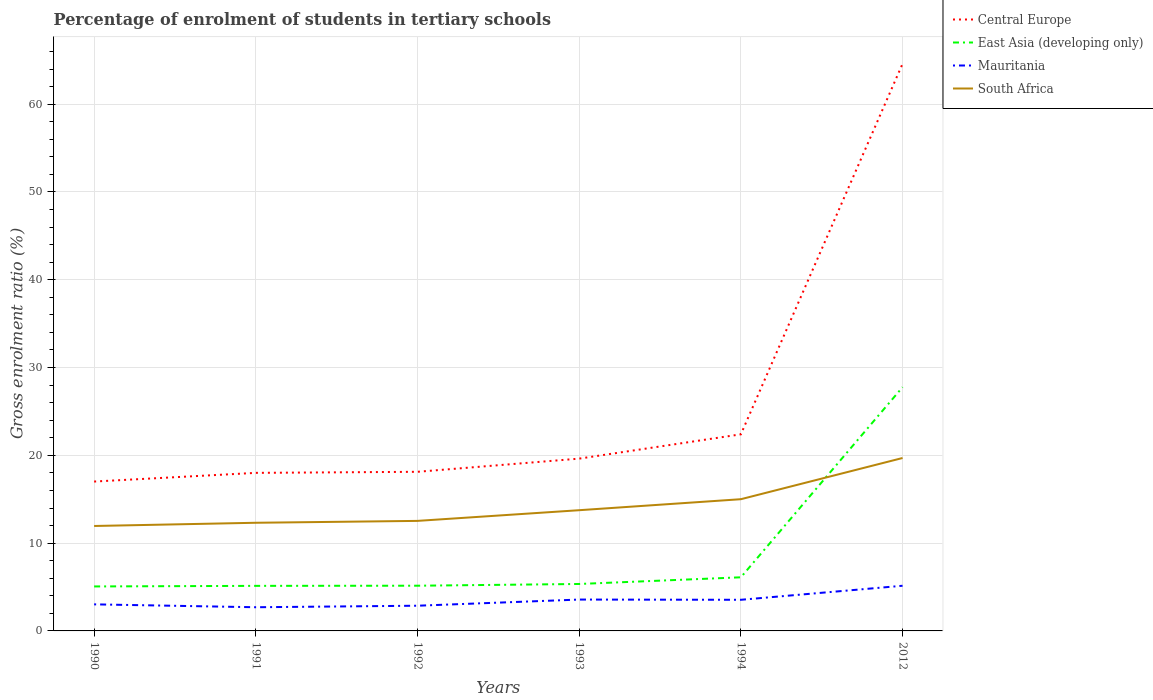How many different coloured lines are there?
Provide a short and direct response. 4. Is the number of lines equal to the number of legend labels?
Your response must be concise. Yes. Across all years, what is the maximum percentage of students enrolled in tertiary schools in East Asia (developing only)?
Your answer should be very brief. 5.07. What is the total percentage of students enrolled in tertiary schools in Mauritania in the graph?
Your answer should be very brief. -0.85. What is the difference between the highest and the second highest percentage of students enrolled in tertiary schools in Mauritania?
Keep it short and to the point. 2.45. What is the difference between the highest and the lowest percentage of students enrolled in tertiary schools in Mauritania?
Offer a very short reply. 3. How many lines are there?
Your answer should be very brief. 4. Does the graph contain grids?
Offer a very short reply. Yes. Where does the legend appear in the graph?
Offer a terse response. Top right. How are the legend labels stacked?
Offer a terse response. Vertical. What is the title of the graph?
Offer a terse response. Percentage of enrolment of students in tertiary schools. What is the label or title of the X-axis?
Keep it short and to the point. Years. What is the label or title of the Y-axis?
Provide a succinct answer. Gross enrolment ratio (%). What is the Gross enrolment ratio (%) in Central Europe in 1990?
Offer a very short reply. 17.02. What is the Gross enrolment ratio (%) in East Asia (developing only) in 1990?
Provide a short and direct response. 5.07. What is the Gross enrolment ratio (%) in Mauritania in 1990?
Your answer should be compact. 3.03. What is the Gross enrolment ratio (%) of South Africa in 1990?
Keep it short and to the point. 11.95. What is the Gross enrolment ratio (%) in Central Europe in 1991?
Provide a short and direct response. 18. What is the Gross enrolment ratio (%) in East Asia (developing only) in 1991?
Keep it short and to the point. 5.13. What is the Gross enrolment ratio (%) in Mauritania in 1991?
Your answer should be compact. 2.7. What is the Gross enrolment ratio (%) of South Africa in 1991?
Provide a succinct answer. 12.32. What is the Gross enrolment ratio (%) of Central Europe in 1992?
Provide a succinct answer. 18.13. What is the Gross enrolment ratio (%) in East Asia (developing only) in 1992?
Your response must be concise. 5.15. What is the Gross enrolment ratio (%) in Mauritania in 1992?
Give a very brief answer. 2.87. What is the Gross enrolment ratio (%) of South Africa in 1992?
Your answer should be compact. 12.53. What is the Gross enrolment ratio (%) of Central Europe in 1993?
Offer a terse response. 19.63. What is the Gross enrolment ratio (%) in East Asia (developing only) in 1993?
Your answer should be very brief. 5.35. What is the Gross enrolment ratio (%) in Mauritania in 1993?
Ensure brevity in your answer.  3.57. What is the Gross enrolment ratio (%) in South Africa in 1993?
Provide a succinct answer. 13.75. What is the Gross enrolment ratio (%) of Central Europe in 1994?
Your answer should be compact. 22.4. What is the Gross enrolment ratio (%) of East Asia (developing only) in 1994?
Your response must be concise. 6.11. What is the Gross enrolment ratio (%) in Mauritania in 1994?
Make the answer very short. 3.55. What is the Gross enrolment ratio (%) in South Africa in 1994?
Your answer should be very brief. 15. What is the Gross enrolment ratio (%) in Central Europe in 2012?
Ensure brevity in your answer.  64.61. What is the Gross enrolment ratio (%) of East Asia (developing only) in 2012?
Ensure brevity in your answer.  27.76. What is the Gross enrolment ratio (%) in Mauritania in 2012?
Your answer should be compact. 5.14. What is the Gross enrolment ratio (%) of South Africa in 2012?
Provide a succinct answer. 19.7. Across all years, what is the maximum Gross enrolment ratio (%) of Central Europe?
Offer a terse response. 64.61. Across all years, what is the maximum Gross enrolment ratio (%) in East Asia (developing only)?
Your answer should be very brief. 27.76. Across all years, what is the maximum Gross enrolment ratio (%) in Mauritania?
Make the answer very short. 5.14. Across all years, what is the maximum Gross enrolment ratio (%) of South Africa?
Your answer should be compact. 19.7. Across all years, what is the minimum Gross enrolment ratio (%) in Central Europe?
Offer a very short reply. 17.02. Across all years, what is the minimum Gross enrolment ratio (%) of East Asia (developing only)?
Your answer should be very brief. 5.07. Across all years, what is the minimum Gross enrolment ratio (%) in Mauritania?
Offer a very short reply. 2.7. Across all years, what is the minimum Gross enrolment ratio (%) of South Africa?
Your response must be concise. 11.95. What is the total Gross enrolment ratio (%) of Central Europe in the graph?
Provide a succinct answer. 159.77. What is the total Gross enrolment ratio (%) of East Asia (developing only) in the graph?
Provide a short and direct response. 54.57. What is the total Gross enrolment ratio (%) of Mauritania in the graph?
Offer a terse response. 20.86. What is the total Gross enrolment ratio (%) in South Africa in the graph?
Make the answer very short. 85.26. What is the difference between the Gross enrolment ratio (%) in Central Europe in 1990 and that in 1991?
Offer a very short reply. -0.99. What is the difference between the Gross enrolment ratio (%) in East Asia (developing only) in 1990 and that in 1991?
Give a very brief answer. -0.07. What is the difference between the Gross enrolment ratio (%) in Mauritania in 1990 and that in 1991?
Ensure brevity in your answer.  0.33. What is the difference between the Gross enrolment ratio (%) of South Africa in 1990 and that in 1991?
Ensure brevity in your answer.  -0.37. What is the difference between the Gross enrolment ratio (%) of Central Europe in 1990 and that in 1992?
Your response must be concise. -1.11. What is the difference between the Gross enrolment ratio (%) in East Asia (developing only) in 1990 and that in 1992?
Give a very brief answer. -0.08. What is the difference between the Gross enrolment ratio (%) in Mauritania in 1990 and that in 1992?
Ensure brevity in your answer.  0.16. What is the difference between the Gross enrolment ratio (%) of South Africa in 1990 and that in 1992?
Offer a very short reply. -0.58. What is the difference between the Gross enrolment ratio (%) in Central Europe in 1990 and that in 1993?
Provide a succinct answer. -2.61. What is the difference between the Gross enrolment ratio (%) of East Asia (developing only) in 1990 and that in 1993?
Give a very brief answer. -0.28. What is the difference between the Gross enrolment ratio (%) in Mauritania in 1990 and that in 1993?
Offer a terse response. -0.55. What is the difference between the Gross enrolment ratio (%) of South Africa in 1990 and that in 1993?
Your answer should be compact. -1.8. What is the difference between the Gross enrolment ratio (%) of Central Europe in 1990 and that in 1994?
Provide a succinct answer. -5.38. What is the difference between the Gross enrolment ratio (%) in East Asia (developing only) in 1990 and that in 1994?
Offer a very short reply. -1.04. What is the difference between the Gross enrolment ratio (%) in Mauritania in 1990 and that in 1994?
Offer a very short reply. -0.52. What is the difference between the Gross enrolment ratio (%) of South Africa in 1990 and that in 1994?
Your response must be concise. -3.05. What is the difference between the Gross enrolment ratio (%) of Central Europe in 1990 and that in 2012?
Your answer should be very brief. -47.59. What is the difference between the Gross enrolment ratio (%) of East Asia (developing only) in 1990 and that in 2012?
Your answer should be compact. -22.7. What is the difference between the Gross enrolment ratio (%) of Mauritania in 1990 and that in 2012?
Make the answer very short. -2.12. What is the difference between the Gross enrolment ratio (%) in South Africa in 1990 and that in 2012?
Your answer should be very brief. -7.74. What is the difference between the Gross enrolment ratio (%) in Central Europe in 1991 and that in 1992?
Ensure brevity in your answer.  -0.12. What is the difference between the Gross enrolment ratio (%) in East Asia (developing only) in 1991 and that in 1992?
Your answer should be compact. -0.02. What is the difference between the Gross enrolment ratio (%) in Mauritania in 1991 and that in 1992?
Offer a very short reply. -0.17. What is the difference between the Gross enrolment ratio (%) of South Africa in 1991 and that in 1992?
Ensure brevity in your answer.  -0.21. What is the difference between the Gross enrolment ratio (%) of Central Europe in 1991 and that in 1993?
Your answer should be very brief. -1.62. What is the difference between the Gross enrolment ratio (%) of East Asia (developing only) in 1991 and that in 1993?
Offer a terse response. -0.21. What is the difference between the Gross enrolment ratio (%) in Mauritania in 1991 and that in 1993?
Offer a terse response. -0.88. What is the difference between the Gross enrolment ratio (%) in South Africa in 1991 and that in 1993?
Make the answer very short. -1.43. What is the difference between the Gross enrolment ratio (%) of Central Europe in 1991 and that in 1994?
Make the answer very short. -4.39. What is the difference between the Gross enrolment ratio (%) of East Asia (developing only) in 1991 and that in 1994?
Provide a succinct answer. -0.98. What is the difference between the Gross enrolment ratio (%) in Mauritania in 1991 and that in 1994?
Offer a terse response. -0.85. What is the difference between the Gross enrolment ratio (%) in South Africa in 1991 and that in 1994?
Provide a succinct answer. -2.68. What is the difference between the Gross enrolment ratio (%) of Central Europe in 1991 and that in 2012?
Your answer should be compact. -46.6. What is the difference between the Gross enrolment ratio (%) in East Asia (developing only) in 1991 and that in 2012?
Your answer should be compact. -22.63. What is the difference between the Gross enrolment ratio (%) in Mauritania in 1991 and that in 2012?
Provide a succinct answer. -2.45. What is the difference between the Gross enrolment ratio (%) in South Africa in 1991 and that in 2012?
Keep it short and to the point. -7.38. What is the difference between the Gross enrolment ratio (%) in Central Europe in 1992 and that in 1993?
Provide a short and direct response. -1.5. What is the difference between the Gross enrolment ratio (%) in East Asia (developing only) in 1992 and that in 1993?
Ensure brevity in your answer.  -0.2. What is the difference between the Gross enrolment ratio (%) of Mauritania in 1992 and that in 1993?
Make the answer very short. -0.7. What is the difference between the Gross enrolment ratio (%) in South Africa in 1992 and that in 1993?
Give a very brief answer. -1.22. What is the difference between the Gross enrolment ratio (%) of Central Europe in 1992 and that in 1994?
Your response must be concise. -4.27. What is the difference between the Gross enrolment ratio (%) in East Asia (developing only) in 1992 and that in 1994?
Your answer should be very brief. -0.96. What is the difference between the Gross enrolment ratio (%) of Mauritania in 1992 and that in 1994?
Offer a very short reply. -0.68. What is the difference between the Gross enrolment ratio (%) in South Africa in 1992 and that in 1994?
Make the answer very short. -2.47. What is the difference between the Gross enrolment ratio (%) of Central Europe in 1992 and that in 2012?
Offer a very short reply. -46.48. What is the difference between the Gross enrolment ratio (%) of East Asia (developing only) in 1992 and that in 2012?
Keep it short and to the point. -22.61. What is the difference between the Gross enrolment ratio (%) of Mauritania in 1992 and that in 2012?
Provide a short and direct response. -2.27. What is the difference between the Gross enrolment ratio (%) of South Africa in 1992 and that in 2012?
Offer a very short reply. -7.16. What is the difference between the Gross enrolment ratio (%) in Central Europe in 1993 and that in 1994?
Provide a short and direct response. -2.77. What is the difference between the Gross enrolment ratio (%) in East Asia (developing only) in 1993 and that in 1994?
Ensure brevity in your answer.  -0.76. What is the difference between the Gross enrolment ratio (%) in Mauritania in 1993 and that in 1994?
Provide a short and direct response. 0.03. What is the difference between the Gross enrolment ratio (%) in South Africa in 1993 and that in 1994?
Make the answer very short. -1.25. What is the difference between the Gross enrolment ratio (%) of Central Europe in 1993 and that in 2012?
Your answer should be very brief. -44.98. What is the difference between the Gross enrolment ratio (%) in East Asia (developing only) in 1993 and that in 2012?
Offer a terse response. -22.42. What is the difference between the Gross enrolment ratio (%) in Mauritania in 1993 and that in 2012?
Your answer should be compact. -1.57. What is the difference between the Gross enrolment ratio (%) in South Africa in 1993 and that in 2012?
Offer a very short reply. -5.95. What is the difference between the Gross enrolment ratio (%) in Central Europe in 1994 and that in 2012?
Provide a short and direct response. -42.21. What is the difference between the Gross enrolment ratio (%) of East Asia (developing only) in 1994 and that in 2012?
Provide a succinct answer. -21.66. What is the difference between the Gross enrolment ratio (%) in Mauritania in 1994 and that in 2012?
Your response must be concise. -1.6. What is the difference between the Gross enrolment ratio (%) in South Africa in 1994 and that in 2012?
Make the answer very short. -4.69. What is the difference between the Gross enrolment ratio (%) in Central Europe in 1990 and the Gross enrolment ratio (%) in East Asia (developing only) in 1991?
Your answer should be compact. 11.88. What is the difference between the Gross enrolment ratio (%) in Central Europe in 1990 and the Gross enrolment ratio (%) in Mauritania in 1991?
Provide a succinct answer. 14.32. What is the difference between the Gross enrolment ratio (%) in Central Europe in 1990 and the Gross enrolment ratio (%) in South Africa in 1991?
Make the answer very short. 4.7. What is the difference between the Gross enrolment ratio (%) of East Asia (developing only) in 1990 and the Gross enrolment ratio (%) of Mauritania in 1991?
Keep it short and to the point. 2.37. What is the difference between the Gross enrolment ratio (%) in East Asia (developing only) in 1990 and the Gross enrolment ratio (%) in South Africa in 1991?
Offer a terse response. -7.25. What is the difference between the Gross enrolment ratio (%) of Mauritania in 1990 and the Gross enrolment ratio (%) of South Africa in 1991?
Ensure brevity in your answer.  -9.29. What is the difference between the Gross enrolment ratio (%) in Central Europe in 1990 and the Gross enrolment ratio (%) in East Asia (developing only) in 1992?
Give a very brief answer. 11.87. What is the difference between the Gross enrolment ratio (%) in Central Europe in 1990 and the Gross enrolment ratio (%) in Mauritania in 1992?
Offer a terse response. 14.14. What is the difference between the Gross enrolment ratio (%) in Central Europe in 1990 and the Gross enrolment ratio (%) in South Africa in 1992?
Make the answer very short. 4.48. What is the difference between the Gross enrolment ratio (%) of East Asia (developing only) in 1990 and the Gross enrolment ratio (%) of Mauritania in 1992?
Make the answer very short. 2.2. What is the difference between the Gross enrolment ratio (%) of East Asia (developing only) in 1990 and the Gross enrolment ratio (%) of South Africa in 1992?
Your answer should be compact. -7.47. What is the difference between the Gross enrolment ratio (%) of Mauritania in 1990 and the Gross enrolment ratio (%) of South Africa in 1992?
Make the answer very short. -9.51. What is the difference between the Gross enrolment ratio (%) of Central Europe in 1990 and the Gross enrolment ratio (%) of East Asia (developing only) in 1993?
Offer a very short reply. 11.67. What is the difference between the Gross enrolment ratio (%) of Central Europe in 1990 and the Gross enrolment ratio (%) of Mauritania in 1993?
Offer a very short reply. 13.44. What is the difference between the Gross enrolment ratio (%) of Central Europe in 1990 and the Gross enrolment ratio (%) of South Africa in 1993?
Provide a short and direct response. 3.26. What is the difference between the Gross enrolment ratio (%) in East Asia (developing only) in 1990 and the Gross enrolment ratio (%) in Mauritania in 1993?
Offer a very short reply. 1.49. What is the difference between the Gross enrolment ratio (%) in East Asia (developing only) in 1990 and the Gross enrolment ratio (%) in South Africa in 1993?
Keep it short and to the point. -8.68. What is the difference between the Gross enrolment ratio (%) of Mauritania in 1990 and the Gross enrolment ratio (%) of South Africa in 1993?
Keep it short and to the point. -10.72. What is the difference between the Gross enrolment ratio (%) in Central Europe in 1990 and the Gross enrolment ratio (%) in East Asia (developing only) in 1994?
Offer a terse response. 10.91. What is the difference between the Gross enrolment ratio (%) of Central Europe in 1990 and the Gross enrolment ratio (%) of Mauritania in 1994?
Your response must be concise. 13.47. What is the difference between the Gross enrolment ratio (%) in Central Europe in 1990 and the Gross enrolment ratio (%) in South Africa in 1994?
Give a very brief answer. 2.01. What is the difference between the Gross enrolment ratio (%) of East Asia (developing only) in 1990 and the Gross enrolment ratio (%) of Mauritania in 1994?
Provide a short and direct response. 1.52. What is the difference between the Gross enrolment ratio (%) in East Asia (developing only) in 1990 and the Gross enrolment ratio (%) in South Africa in 1994?
Your answer should be compact. -9.94. What is the difference between the Gross enrolment ratio (%) of Mauritania in 1990 and the Gross enrolment ratio (%) of South Africa in 1994?
Give a very brief answer. -11.98. What is the difference between the Gross enrolment ratio (%) in Central Europe in 1990 and the Gross enrolment ratio (%) in East Asia (developing only) in 2012?
Provide a succinct answer. -10.75. What is the difference between the Gross enrolment ratio (%) in Central Europe in 1990 and the Gross enrolment ratio (%) in Mauritania in 2012?
Provide a short and direct response. 11.87. What is the difference between the Gross enrolment ratio (%) in Central Europe in 1990 and the Gross enrolment ratio (%) in South Africa in 2012?
Your answer should be very brief. -2.68. What is the difference between the Gross enrolment ratio (%) in East Asia (developing only) in 1990 and the Gross enrolment ratio (%) in Mauritania in 2012?
Offer a terse response. -0.08. What is the difference between the Gross enrolment ratio (%) of East Asia (developing only) in 1990 and the Gross enrolment ratio (%) of South Africa in 2012?
Give a very brief answer. -14.63. What is the difference between the Gross enrolment ratio (%) in Mauritania in 1990 and the Gross enrolment ratio (%) in South Africa in 2012?
Give a very brief answer. -16.67. What is the difference between the Gross enrolment ratio (%) of Central Europe in 1991 and the Gross enrolment ratio (%) of East Asia (developing only) in 1992?
Offer a terse response. 12.85. What is the difference between the Gross enrolment ratio (%) in Central Europe in 1991 and the Gross enrolment ratio (%) in Mauritania in 1992?
Provide a succinct answer. 15.13. What is the difference between the Gross enrolment ratio (%) of Central Europe in 1991 and the Gross enrolment ratio (%) of South Africa in 1992?
Make the answer very short. 5.47. What is the difference between the Gross enrolment ratio (%) in East Asia (developing only) in 1991 and the Gross enrolment ratio (%) in Mauritania in 1992?
Give a very brief answer. 2.26. What is the difference between the Gross enrolment ratio (%) of East Asia (developing only) in 1991 and the Gross enrolment ratio (%) of South Africa in 1992?
Give a very brief answer. -7.4. What is the difference between the Gross enrolment ratio (%) in Mauritania in 1991 and the Gross enrolment ratio (%) in South Africa in 1992?
Your answer should be very brief. -9.84. What is the difference between the Gross enrolment ratio (%) in Central Europe in 1991 and the Gross enrolment ratio (%) in East Asia (developing only) in 1993?
Provide a short and direct response. 12.66. What is the difference between the Gross enrolment ratio (%) of Central Europe in 1991 and the Gross enrolment ratio (%) of Mauritania in 1993?
Your answer should be very brief. 14.43. What is the difference between the Gross enrolment ratio (%) in Central Europe in 1991 and the Gross enrolment ratio (%) in South Africa in 1993?
Ensure brevity in your answer.  4.25. What is the difference between the Gross enrolment ratio (%) in East Asia (developing only) in 1991 and the Gross enrolment ratio (%) in Mauritania in 1993?
Make the answer very short. 1.56. What is the difference between the Gross enrolment ratio (%) in East Asia (developing only) in 1991 and the Gross enrolment ratio (%) in South Africa in 1993?
Ensure brevity in your answer.  -8.62. What is the difference between the Gross enrolment ratio (%) of Mauritania in 1991 and the Gross enrolment ratio (%) of South Africa in 1993?
Your response must be concise. -11.05. What is the difference between the Gross enrolment ratio (%) of Central Europe in 1991 and the Gross enrolment ratio (%) of East Asia (developing only) in 1994?
Keep it short and to the point. 11.9. What is the difference between the Gross enrolment ratio (%) of Central Europe in 1991 and the Gross enrolment ratio (%) of Mauritania in 1994?
Keep it short and to the point. 14.46. What is the difference between the Gross enrolment ratio (%) of East Asia (developing only) in 1991 and the Gross enrolment ratio (%) of Mauritania in 1994?
Offer a very short reply. 1.59. What is the difference between the Gross enrolment ratio (%) of East Asia (developing only) in 1991 and the Gross enrolment ratio (%) of South Africa in 1994?
Provide a short and direct response. -9.87. What is the difference between the Gross enrolment ratio (%) of Mauritania in 1991 and the Gross enrolment ratio (%) of South Africa in 1994?
Your answer should be very brief. -12.31. What is the difference between the Gross enrolment ratio (%) of Central Europe in 1991 and the Gross enrolment ratio (%) of East Asia (developing only) in 2012?
Offer a very short reply. -9.76. What is the difference between the Gross enrolment ratio (%) of Central Europe in 1991 and the Gross enrolment ratio (%) of Mauritania in 2012?
Your answer should be compact. 12.86. What is the difference between the Gross enrolment ratio (%) in Central Europe in 1991 and the Gross enrolment ratio (%) in South Africa in 2012?
Give a very brief answer. -1.69. What is the difference between the Gross enrolment ratio (%) in East Asia (developing only) in 1991 and the Gross enrolment ratio (%) in Mauritania in 2012?
Your answer should be compact. -0.01. What is the difference between the Gross enrolment ratio (%) of East Asia (developing only) in 1991 and the Gross enrolment ratio (%) of South Africa in 2012?
Offer a terse response. -14.56. What is the difference between the Gross enrolment ratio (%) in Mauritania in 1991 and the Gross enrolment ratio (%) in South Africa in 2012?
Make the answer very short. -17. What is the difference between the Gross enrolment ratio (%) in Central Europe in 1992 and the Gross enrolment ratio (%) in East Asia (developing only) in 1993?
Give a very brief answer. 12.78. What is the difference between the Gross enrolment ratio (%) in Central Europe in 1992 and the Gross enrolment ratio (%) in Mauritania in 1993?
Keep it short and to the point. 14.55. What is the difference between the Gross enrolment ratio (%) of Central Europe in 1992 and the Gross enrolment ratio (%) of South Africa in 1993?
Your answer should be compact. 4.37. What is the difference between the Gross enrolment ratio (%) in East Asia (developing only) in 1992 and the Gross enrolment ratio (%) in Mauritania in 1993?
Ensure brevity in your answer.  1.58. What is the difference between the Gross enrolment ratio (%) in East Asia (developing only) in 1992 and the Gross enrolment ratio (%) in South Africa in 1993?
Offer a very short reply. -8.6. What is the difference between the Gross enrolment ratio (%) of Mauritania in 1992 and the Gross enrolment ratio (%) of South Africa in 1993?
Offer a terse response. -10.88. What is the difference between the Gross enrolment ratio (%) in Central Europe in 1992 and the Gross enrolment ratio (%) in East Asia (developing only) in 1994?
Your answer should be very brief. 12.02. What is the difference between the Gross enrolment ratio (%) of Central Europe in 1992 and the Gross enrolment ratio (%) of Mauritania in 1994?
Provide a short and direct response. 14.58. What is the difference between the Gross enrolment ratio (%) of Central Europe in 1992 and the Gross enrolment ratio (%) of South Africa in 1994?
Provide a succinct answer. 3.12. What is the difference between the Gross enrolment ratio (%) of East Asia (developing only) in 1992 and the Gross enrolment ratio (%) of Mauritania in 1994?
Provide a short and direct response. 1.6. What is the difference between the Gross enrolment ratio (%) of East Asia (developing only) in 1992 and the Gross enrolment ratio (%) of South Africa in 1994?
Provide a short and direct response. -9.85. What is the difference between the Gross enrolment ratio (%) in Mauritania in 1992 and the Gross enrolment ratio (%) in South Africa in 1994?
Offer a terse response. -12.13. What is the difference between the Gross enrolment ratio (%) in Central Europe in 1992 and the Gross enrolment ratio (%) in East Asia (developing only) in 2012?
Your answer should be very brief. -9.64. What is the difference between the Gross enrolment ratio (%) of Central Europe in 1992 and the Gross enrolment ratio (%) of Mauritania in 2012?
Ensure brevity in your answer.  12.98. What is the difference between the Gross enrolment ratio (%) in Central Europe in 1992 and the Gross enrolment ratio (%) in South Africa in 2012?
Your answer should be very brief. -1.57. What is the difference between the Gross enrolment ratio (%) in East Asia (developing only) in 1992 and the Gross enrolment ratio (%) in Mauritania in 2012?
Keep it short and to the point. 0.01. What is the difference between the Gross enrolment ratio (%) in East Asia (developing only) in 1992 and the Gross enrolment ratio (%) in South Africa in 2012?
Provide a succinct answer. -14.55. What is the difference between the Gross enrolment ratio (%) in Mauritania in 1992 and the Gross enrolment ratio (%) in South Africa in 2012?
Your answer should be compact. -16.83. What is the difference between the Gross enrolment ratio (%) in Central Europe in 1993 and the Gross enrolment ratio (%) in East Asia (developing only) in 1994?
Your answer should be very brief. 13.52. What is the difference between the Gross enrolment ratio (%) of Central Europe in 1993 and the Gross enrolment ratio (%) of Mauritania in 1994?
Your answer should be very brief. 16.08. What is the difference between the Gross enrolment ratio (%) of Central Europe in 1993 and the Gross enrolment ratio (%) of South Africa in 1994?
Keep it short and to the point. 4.62. What is the difference between the Gross enrolment ratio (%) of East Asia (developing only) in 1993 and the Gross enrolment ratio (%) of Mauritania in 1994?
Make the answer very short. 1.8. What is the difference between the Gross enrolment ratio (%) of East Asia (developing only) in 1993 and the Gross enrolment ratio (%) of South Africa in 1994?
Offer a very short reply. -9.66. What is the difference between the Gross enrolment ratio (%) of Mauritania in 1993 and the Gross enrolment ratio (%) of South Africa in 1994?
Keep it short and to the point. -11.43. What is the difference between the Gross enrolment ratio (%) of Central Europe in 1993 and the Gross enrolment ratio (%) of East Asia (developing only) in 2012?
Ensure brevity in your answer.  -8.14. What is the difference between the Gross enrolment ratio (%) of Central Europe in 1993 and the Gross enrolment ratio (%) of Mauritania in 2012?
Your answer should be very brief. 14.48. What is the difference between the Gross enrolment ratio (%) in Central Europe in 1993 and the Gross enrolment ratio (%) in South Africa in 2012?
Your answer should be very brief. -0.07. What is the difference between the Gross enrolment ratio (%) in East Asia (developing only) in 1993 and the Gross enrolment ratio (%) in Mauritania in 2012?
Offer a very short reply. 0.2. What is the difference between the Gross enrolment ratio (%) in East Asia (developing only) in 1993 and the Gross enrolment ratio (%) in South Africa in 2012?
Provide a succinct answer. -14.35. What is the difference between the Gross enrolment ratio (%) of Mauritania in 1993 and the Gross enrolment ratio (%) of South Africa in 2012?
Give a very brief answer. -16.12. What is the difference between the Gross enrolment ratio (%) of Central Europe in 1994 and the Gross enrolment ratio (%) of East Asia (developing only) in 2012?
Provide a short and direct response. -5.37. What is the difference between the Gross enrolment ratio (%) of Central Europe in 1994 and the Gross enrolment ratio (%) of Mauritania in 2012?
Offer a terse response. 17.25. What is the difference between the Gross enrolment ratio (%) in Central Europe in 1994 and the Gross enrolment ratio (%) in South Africa in 2012?
Make the answer very short. 2.7. What is the difference between the Gross enrolment ratio (%) of East Asia (developing only) in 1994 and the Gross enrolment ratio (%) of Mauritania in 2012?
Your response must be concise. 0.96. What is the difference between the Gross enrolment ratio (%) in East Asia (developing only) in 1994 and the Gross enrolment ratio (%) in South Africa in 2012?
Your answer should be very brief. -13.59. What is the difference between the Gross enrolment ratio (%) of Mauritania in 1994 and the Gross enrolment ratio (%) of South Africa in 2012?
Make the answer very short. -16.15. What is the average Gross enrolment ratio (%) in Central Europe per year?
Give a very brief answer. 26.63. What is the average Gross enrolment ratio (%) of East Asia (developing only) per year?
Ensure brevity in your answer.  9.09. What is the average Gross enrolment ratio (%) of Mauritania per year?
Offer a terse response. 3.48. What is the average Gross enrolment ratio (%) of South Africa per year?
Your answer should be compact. 14.21. In the year 1990, what is the difference between the Gross enrolment ratio (%) of Central Europe and Gross enrolment ratio (%) of East Asia (developing only)?
Your response must be concise. 11.95. In the year 1990, what is the difference between the Gross enrolment ratio (%) of Central Europe and Gross enrolment ratio (%) of Mauritania?
Offer a terse response. 13.99. In the year 1990, what is the difference between the Gross enrolment ratio (%) in Central Europe and Gross enrolment ratio (%) in South Africa?
Give a very brief answer. 5.06. In the year 1990, what is the difference between the Gross enrolment ratio (%) of East Asia (developing only) and Gross enrolment ratio (%) of Mauritania?
Offer a terse response. 2.04. In the year 1990, what is the difference between the Gross enrolment ratio (%) in East Asia (developing only) and Gross enrolment ratio (%) in South Africa?
Your answer should be very brief. -6.89. In the year 1990, what is the difference between the Gross enrolment ratio (%) of Mauritania and Gross enrolment ratio (%) of South Africa?
Give a very brief answer. -8.93. In the year 1991, what is the difference between the Gross enrolment ratio (%) of Central Europe and Gross enrolment ratio (%) of East Asia (developing only)?
Provide a succinct answer. 12.87. In the year 1991, what is the difference between the Gross enrolment ratio (%) in Central Europe and Gross enrolment ratio (%) in Mauritania?
Make the answer very short. 15.31. In the year 1991, what is the difference between the Gross enrolment ratio (%) of Central Europe and Gross enrolment ratio (%) of South Africa?
Your response must be concise. 5.68. In the year 1991, what is the difference between the Gross enrolment ratio (%) in East Asia (developing only) and Gross enrolment ratio (%) in Mauritania?
Ensure brevity in your answer.  2.44. In the year 1991, what is the difference between the Gross enrolment ratio (%) of East Asia (developing only) and Gross enrolment ratio (%) of South Africa?
Offer a very short reply. -7.19. In the year 1991, what is the difference between the Gross enrolment ratio (%) of Mauritania and Gross enrolment ratio (%) of South Africa?
Provide a succinct answer. -9.62. In the year 1992, what is the difference between the Gross enrolment ratio (%) of Central Europe and Gross enrolment ratio (%) of East Asia (developing only)?
Keep it short and to the point. 12.98. In the year 1992, what is the difference between the Gross enrolment ratio (%) in Central Europe and Gross enrolment ratio (%) in Mauritania?
Provide a short and direct response. 15.25. In the year 1992, what is the difference between the Gross enrolment ratio (%) in Central Europe and Gross enrolment ratio (%) in South Africa?
Keep it short and to the point. 5.59. In the year 1992, what is the difference between the Gross enrolment ratio (%) in East Asia (developing only) and Gross enrolment ratio (%) in Mauritania?
Offer a terse response. 2.28. In the year 1992, what is the difference between the Gross enrolment ratio (%) in East Asia (developing only) and Gross enrolment ratio (%) in South Africa?
Provide a short and direct response. -7.38. In the year 1992, what is the difference between the Gross enrolment ratio (%) in Mauritania and Gross enrolment ratio (%) in South Africa?
Keep it short and to the point. -9.66. In the year 1993, what is the difference between the Gross enrolment ratio (%) of Central Europe and Gross enrolment ratio (%) of East Asia (developing only)?
Provide a succinct answer. 14.28. In the year 1993, what is the difference between the Gross enrolment ratio (%) of Central Europe and Gross enrolment ratio (%) of Mauritania?
Offer a very short reply. 16.05. In the year 1993, what is the difference between the Gross enrolment ratio (%) in Central Europe and Gross enrolment ratio (%) in South Africa?
Offer a very short reply. 5.87. In the year 1993, what is the difference between the Gross enrolment ratio (%) of East Asia (developing only) and Gross enrolment ratio (%) of Mauritania?
Your answer should be very brief. 1.77. In the year 1993, what is the difference between the Gross enrolment ratio (%) in East Asia (developing only) and Gross enrolment ratio (%) in South Africa?
Give a very brief answer. -8.4. In the year 1993, what is the difference between the Gross enrolment ratio (%) in Mauritania and Gross enrolment ratio (%) in South Africa?
Provide a short and direct response. -10.18. In the year 1994, what is the difference between the Gross enrolment ratio (%) of Central Europe and Gross enrolment ratio (%) of East Asia (developing only)?
Make the answer very short. 16.29. In the year 1994, what is the difference between the Gross enrolment ratio (%) in Central Europe and Gross enrolment ratio (%) in Mauritania?
Offer a terse response. 18.85. In the year 1994, what is the difference between the Gross enrolment ratio (%) in Central Europe and Gross enrolment ratio (%) in South Africa?
Your answer should be very brief. 7.39. In the year 1994, what is the difference between the Gross enrolment ratio (%) in East Asia (developing only) and Gross enrolment ratio (%) in Mauritania?
Make the answer very short. 2.56. In the year 1994, what is the difference between the Gross enrolment ratio (%) of East Asia (developing only) and Gross enrolment ratio (%) of South Africa?
Your response must be concise. -8.9. In the year 1994, what is the difference between the Gross enrolment ratio (%) in Mauritania and Gross enrolment ratio (%) in South Africa?
Make the answer very short. -11.46. In the year 2012, what is the difference between the Gross enrolment ratio (%) in Central Europe and Gross enrolment ratio (%) in East Asia (developing only)?
Offer a very short reply. 36.84. In the year 2012, what is the difference between the Gross enrolment ratio (%) in Central Europe and Gross enrolment ratio (%) in Mauritania?
Provide a short and direct response. 59.46. In the year 2012, what is the difference between the Gross enrolment ratio (%) of Central Europe and Gross enrolment ratio (%) of South Africa?
Provide a succinct answer. 44.91. In the year 2012, what is the difference between the Gross enrolment ratio (%) in East Asia (developing only) and Gross enrolment ratio (%) in Mauritania?
Your answer should be very brief. 22.62. In the year 2012, what is the difference between the Gross enrolment ratio (%) of East Asia (developing only) and Gross enrolment ratio (%) of South Africa?
Give a very brief answer. 8.07. In the year 2012, what is the difference between the Gross enrolment ratio (%) in Mauritania and Gross enrolment ratio (%) in South Africa?
Your response must be concise. -14.55. What is the ratio of the Gross enrolment ratio (%) in Central Europe in 1990 to that in 1991?
Provide a succinct answer. 0.95. What is the ratio of the Gross enrolment ratio (%) of East Asia (developing only) in 1990 to that in 1991?
Provide a succinct answer. 0.99. What is the ratio of the Gross enrolment ratio (%) of Mauritania in 1990 to that in 1991?
Offer a very short reply. 1.12. What is the ratio of the Gross enrolment ratio (%) of South Africa in 1990 to that in 1991?
Ensure brevity in your answer.  0.97. What is the ratio of the Gross enrolment ratio (%) of Central Europe in 1990 to that in 1992?
Offer a terse response. 0.94. What is the ratio of the Gross enrolment ratio (%) of East Asia (developing only) in 1990 to that in 1992?
Your response must be concise. 0.98. What is the ratio of the Gross enrolment ratio (%) of Mauritania in 1990 to that in 1992?
Offer a very short reply. 1.05. What is the ratio of the Gross enrolment ratio (%) of South Africa in 1990 to that in 1992?
Offer a very short reply. 0.95. What is the ratio of the Gross enrolment ratio (%) of Central Europe in 1990 to that in 1993?
Give a very brief answer. 0.87. What is the ratio of the Gross enrolment ratio (%) of East Asia (developing only) in 1990 to that in 1993?
Provide a succinct answer. 0.95. What is the ratio of the Gross enrolment ratio (%) in Mauritania in 1990 to that in 1993?
Ensure brevity in your answer.  0.85. What is the ratio of the Gross enrolment ratio (%) in South Africa in 1990 to that in 1993?
Provide a succinct answer. 0.87. What is the ratio of the Gross enrolment ratio (%) in Central Europe in 1990 to that in 1994?
Give a very brief answer. 0.76. What is the ratio of the Gross enrolment ratio (%) in East Asia (developing only) in 1990 to that in 1994?
Give a very brief answer. 0.83. What is the ratio of the Gross enrolment ratio (%) in Mauritania in 1990 to that in 1994?
Make the answer very short. 0.85. What is the ratio of the Gross enrolment ratio (%) of South Africa in 1990 to that in 1994?
Offer a very short reply. 0.8. What is the ratio of the Gross enrolment ratio (%) in Central Europe in 1990 to that in 2012?
Keep it short and to the point. 0.26. What is the ratio of the Gross enrolment ratio (%) of East Asia (developing only) in 1990 to that in 2012?
Provide a short and direct response. 0.18. What is the ratio of the Gross enrolment ratio (%) in Mauritania in 1990 to that in 2012?
Provide a succinct answer. 0.59. What is the ratio of the Gross enrolment ratio (%) of South Africa in 1990 to that in 2012?
Provide a short and direct response. 0.61. What is the ratio of the Gross enrolment ratio (%) in Central Europe in 1991 to that in 1992?
Ensure brevity in your answer.  0.99. What is the ratio of the Gross enrolment ratio (%) in Mauritania in 1991 to that in 1992?
Offer a terse response. 0.94. What is the ratio of the Gross enrolment ratio (%) in South Africa in 1991 to that in 1992?
Your answer should be very brief. 0.98. What is the ratio of the Gross enrolment ratio (%) of Central Europe in 1991 to that in 1993?
Give a very brief answer. 0.92. What is the ratio of the Gross enrolment ratio (%) in East Asia (developing only) in 1991 to that in 1993?
Offer a very short reply. 0.96. What is the ratio of the Gross enrolment ratio (%) of Mauritania in 1991 to that in 1993?
Your response must be concise. 0.76. What is the ratio of the Gross enrolment ratio (%) of South Africa in 1991 to that in 1993?
Make the answer very short. 0.9. What is the ratio of the Gross enrolment ratio (%) in Central Europe in 1991 to that in 1994?
Provide a succinct answer. 0.8. What is the ratio of the Gross enrolment ratio (%) of East Asia (developing only) in 1991 to that in 1994?
Make the answer very short. 0.84. What is the ratio of the Gross enrolment ratio (%) of Mauritania in 1991 to that in 1994?
Provide a short and direct response. 0.76. What is the ratio of the Gross enrolment ratio (%) of South Africa in 1991 to that in 1994?
Your answer should be very brief. 0.82. What is the ratio of the Gross enrolment ratio (%) in Central Europe in 1991 to that in 2012?
Make the answer very short. 0.28. What is the ratio of the Gross enrolment ratio (%) in East Asia (developing only) in 1991 to that in 2012?
Keep it short and to the point. 0.18. What is the ratio of the Gross enrolment ratio (%) in Mauritania in 1991 to that in 2012?
Make the answer very short. 0.52. What is the ratio of the Gross enrolment ratio (%) of South Africa in 1991 to that in 2012?
Your answer should be very brief. 0.63. What is the ratio of the Gross enrolment ratio (%) in Central Europe in 1992 to that in 1993?
Provide a short and direct response. 0.92. What is the ratio of the Gross enrolment ratio (%) of East Asia (developing only) in 1992 to that in 1993?
Provide a short and direct response. 0.96. What is the ratio of the Gross enrolment ratio (%) of Mauritania in 1992 to that in 1993?
Keep it short and to the point. 0.8. What is the ratio of the Gross enrolment ratio (%) in South Africa in 1992 to that in 1993?
Provide a succinct answer. 0.91. What is the ratio of the Gross enrolment ratio (%) in Central Europe in 1992 to that in 1994?
Give a very brief answer. 0.81. What is the ratio of the Gross enrolment ratio (%) in East Asia (developing only) in 1992 to that in 1994?
Provide a succinct answer. 0.84. What is the ratio of the Gross enrolment ratio (%) of Mauritania in 1992 to that in 1994?
Make the answer very short. 0.81. What is the ratio of the Gross enrolment ratio (%) of South Africa in 1992 to that in 1994?
Make the answer very short. 0.84. What is the ratio of the Gross enrolment ratio (%) of Central Europe in 1992 to that in 2012?
Make the answer very short. 0.28. What is the ratio of the Gross enrolment ratio (%) in East Asia (developing only) in 1992 to that in 2012?
Your answer should be compact. 0.19. What is the ratio of the Gross enrolment ratio (%) of Mauritania in 1992 to that in 2012?
Keep it short and to the point. 0.56. What is the ratio of the Gross enrolment ratio (%) in South Africa in 1992 to that in 2012?
Give a very brief answer. 0.64. What is the ratio of the Gross enrolment ratio (%) in Central Europe in 1993 to that in 1994?
Provide a succinct answer. 0.88. What is the ratio of the Gross enrolment ratio (%) of East Asia (developing only) in 1993 to that in 1994?
Offer a very short reply. 0.88. What is the ratio of the Gross enrolment ratio (%) of Mauritania in 1993 to that in 1994?
Provide a succinct answer. 1.01. What is the ratio of the Gross enrolment ratio (%) of South Africa in 1993 to that in 1994?
Keep it short and to the point. 0.92. What is the ratio of the Gross enrolment ratio (%) in Central Europe in 1993 to that in 2012?
Your answer should be very brief. 0.3. What is the ratio of the Gross enrolment ratio (%) in East Asia (developing only) in 1993 to that in 2012?
Provide a short and direct response. 0.19. What is the ratio of the Gross enrolment ratio (%) in Mauritania in 1993 to that in 2012?
Give a very brief answer. 0.69. What is the ratio of the Gross enrolment ratio (%) in South Africa in 1993 to that in 2012?
Ensure brevity in your answer.  0.7. What is the ratio of the Gross enrolment ratio (%) of Central Europe in 1994 to that in 2012?
Keep it short and to the point. 0.35. What is the ratio of the Gross enrolment ratio (%) of East Asia (developing only) in 1994 to that in 2012?
Keep it short and to the point. 0.22. What is the ratio of the Gross enrolment ratio (%) in Mauritania in 1994 to that in 2012?
Your answer should be very brief. 0.69. What is the ratio of the Gross enrolment ratio (%) of South Africa in 1994 to that in 2012?
Give a very brief answer. 0.76. What is the difference between the highest and the second highest Gross enrolment ratio (%) of Central Europe?
Keep it short and to the point. 42.21. What is the difference between the highest and the second highest Gross enrolment ratio (%) of East Asia (developing only)?
Offer a terse response. 21.66. What is the difference between the highest and the second highest Gross enrolment ratio (%) of Mauritania?
Your answer should be very brief. 1.57. What is the difference between the highest and the second highest Gross enrolment ratio (%) of South Africa?
Ensure brevity in your answer.  4.69. What is the difference between the highest and the lowest Gross enrolment ratio (%) of Central Europe?
Offer a terse response. 47.59. What is the difference between the highest and the lowest Gross enrolment ratio (%) in East Asia (developing only)?
Ensure brevity in your answer.  22.7. What is the difference between the highest and the lowest Gross enrolment ratio (%) of Mauritania?
Your response must be concise. 2.45. What is the difference between the highest and the lowest Gross enrolment ratio (%) in South Africa?
Provide a short and direct response. 7.74. 